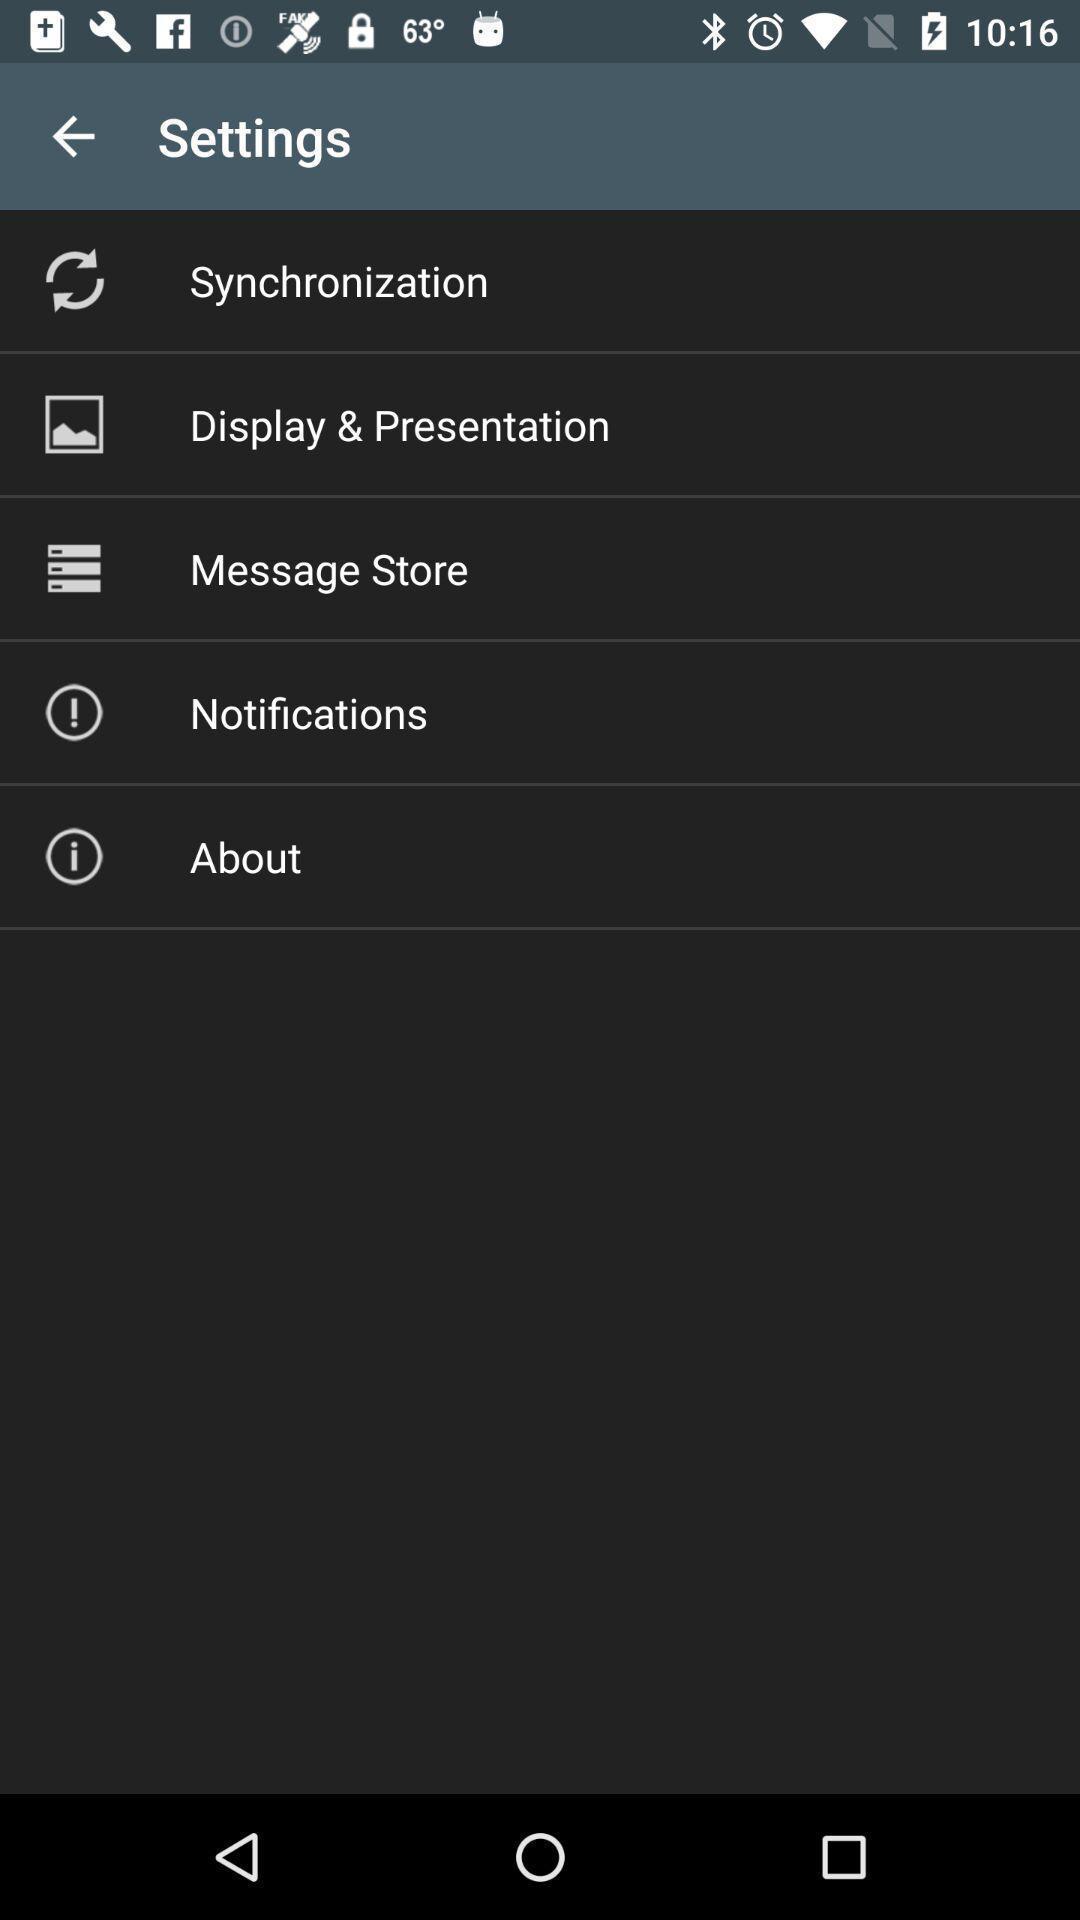Give me a summary of this screen capture. Screen showing list of settings. 